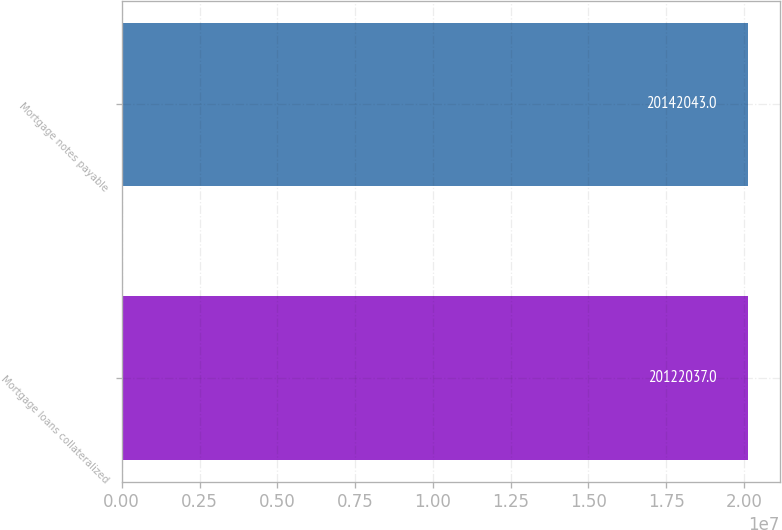Convert chart. <chart><loc_0><loc_0><loc_500><loc_500><bar_chart><fcel>Mortgage loans collateralized<fcel>Mortgage notes payable<nl><fcel>2.0122e+07<fcel>2.0142e+07<nl></chart> 